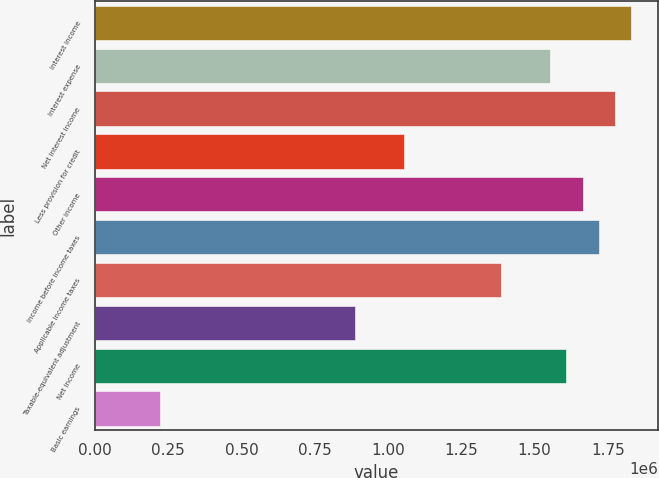Convert chart. <chart><loc_0><loc_0><loc_500><loc_500><bar_chart><fcel>Interest income<fcel>Interest expense<fcel>Net interest income<fcel>Less provision for credit<fcel>Other income<fcel>Income before income taxes<fcel>Applicable income taxes<fcel>Taxable-equivalent adjustment<fcel>Net income<fcel>Basic earnings<nl><fcel>1.83042e+06<fcel>1.55308e+06<fcel>1.77495e+06<fcel>1.05388e+06<fcel>1.66402e+06<fcel>1.71949e+06<fcel>1.38668e+06<fcel>887477<fcel>1.60855e+06<fcel>221869<nl></chart> 